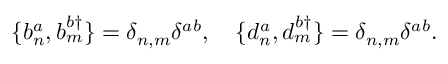Convert formula to latex. <formula><loc_0><loc_0><loc_500><loc_500>\{ b _ { n } ^ { a } , b _ { m } ^ { b \dagger } \} = \delta _ { n , m } \delta ^ { a b } , \quad \{ d _ { n } ^ { a } , d _ { m } ^ { b \dagger } \} = \delta _ { n , m } \delta ^ { a b } .</formula> 